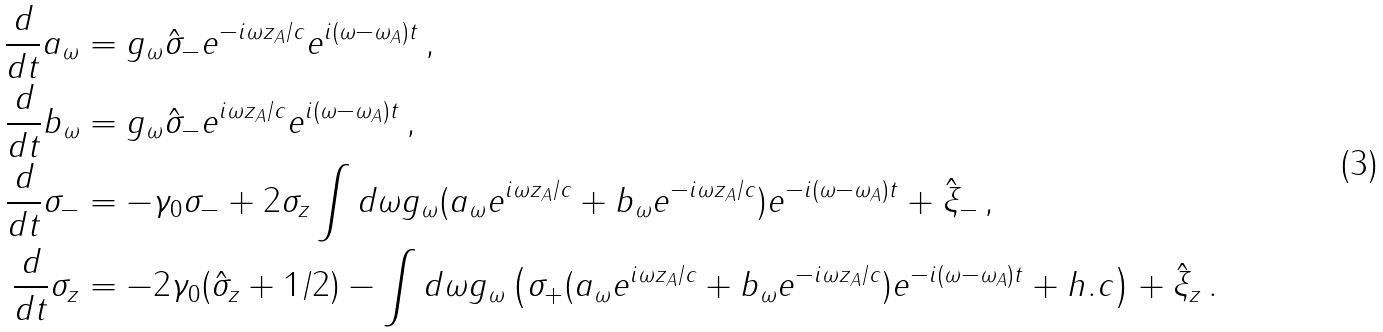<formula> <loc_0><loc_0><loc_500><loc_500>\frac { d } { d t } a _ { \omega } & = g _ { \omega } \hat { \sigma } _ { - } e ^ { - i \omega z _ { A } / c } e ^ { i ( \omega - \omega _ { A } ) t } \, , \\ \frac { d } { d t } b _ { \omega } & = g _ { \omega } \hat { \sigma } _ { - } e ^ { i \omega z _ { A } / c } e ^ { i ( \omega - \omega _ { A } ) t } \, , \\ \frac { d } { d t } \sigma _ { - } & = - \gamma _ { 0 } \sigma _ { - } + 2 \sigma _ { z } \int d \omega g _ { \omega } ( a _ { \omega } e ^ { i \omega z _ { A } / c } + b _ { \omega } e ^ { - i \omega z _ { A } / c } ) e ^ { - i ( \omega - \omega _ { A } ) t } + \hat { \xi } _ { - } \, , \\ \frac { d } { d t } \sigma _ { z } & = - 2 \gamma _ { 0 } ( \hat { \sigma } _ { z } + 1 / 2 ) - \int d \omega g _ { \omega } \left ( \sigma _ { + } ( a _ { \omega } e ^ { i \omega z _ { A } / c } + b _ { \omega } e ^ { - i \omega z _ { A } / c } ) e ^ { - i ( \omega - \omega _ { A } ) t } + h . c \right ) + \hat { \xi } _ { z } \, .</formula> 